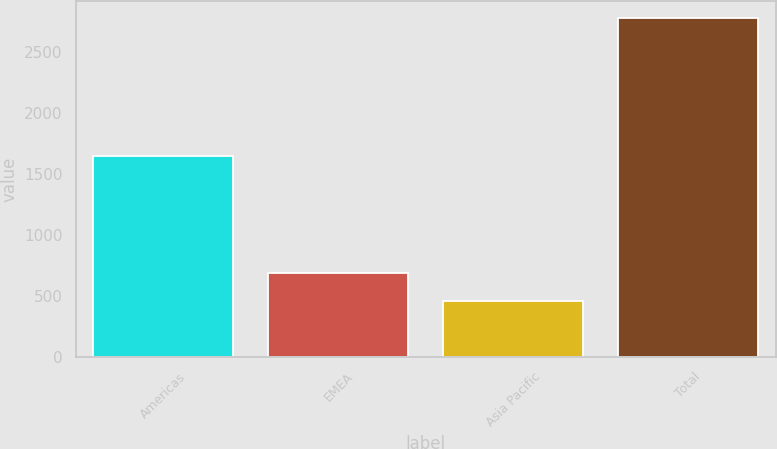Convert chart to OTSL. <chart><loc_0><loc_0><loc_500><loc_500><bar_chart><fcel>Americas<fcel>EMEA<fcel>Asia Pacific<fcel>Total<nl><fcel>1642.7<fcel>690.2<fcel>458.7<fcel>2773.7<nl></chart> 